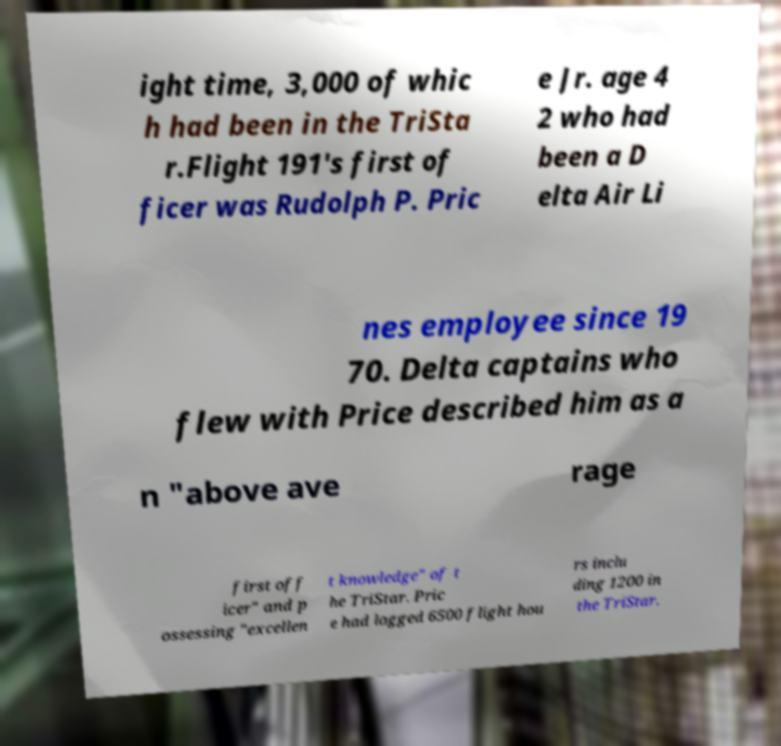I need the written content from this picture converted into text. Can you do that? ight time, 3,000 of whic h had been in the TriSta r.Flight 191's first of ficer was Rudolph P. Pric e Jr. age 4 2 who had been a D elta Air Li nes employee since 19 70. Delta captains who flew with Price described him as a n "above ave rage first off icer" and p ossessing "excellen t knowledge" of t he TriStar. Pric e had logged 6500 flight hou rs inclu ding 1200 in the TriStar. 